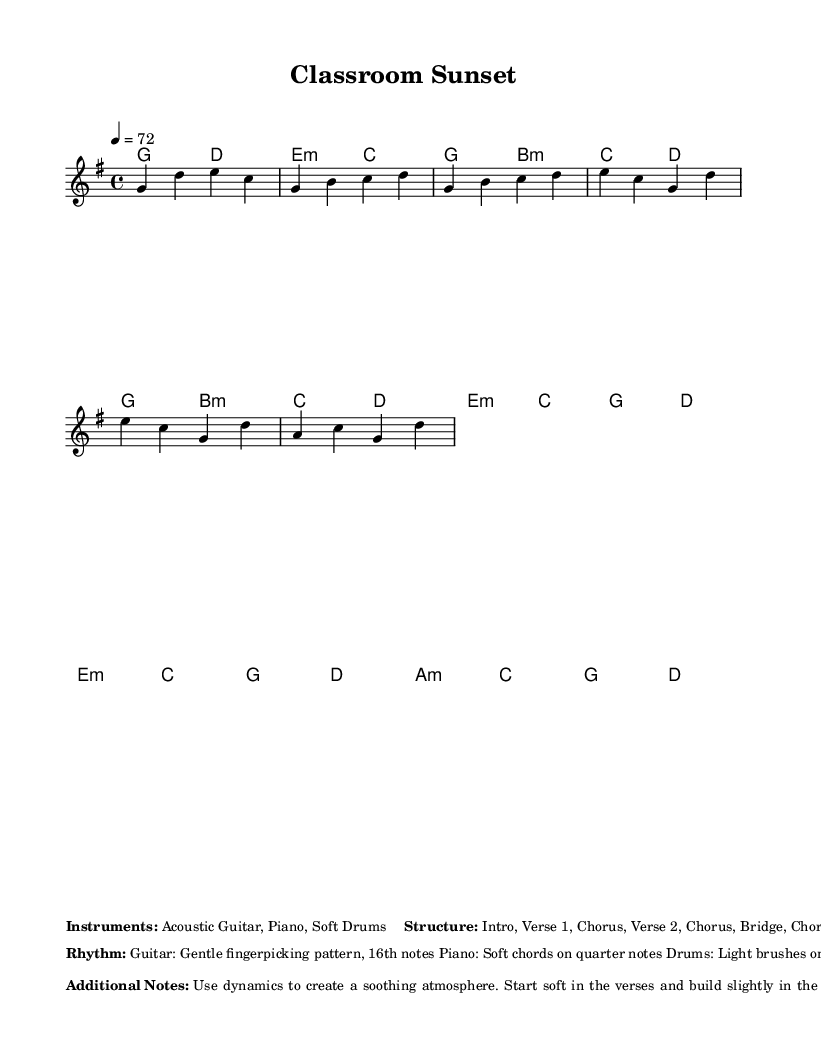What is the key signature of this music? The key signature is G major, which includes one sharp (F#). This can be determined by looking at the key signature symbol placed at the beginning of the staff in the sheet music.
Answer: G major What is the time signature of this piece? The time signature is 4/4, indicated at the beginning of the music. This means that there are four beats in a measure, and the quarter note receives one beat.
Answer: 4/4 What is the tempo marking for this piece? The tempo marking is 72 beats per minute, which is shown as "4 = 72" at the beginning of the score. This means that a quarter note equals 72 beats per minute.
Answer: 72 How many sections does the music contain? The music contains eight sections: Intro, Verse 1, Chorus, Verse 2, Chorus, Bridge, Chorus, and Outro. This can be inferred from the structure outlined in the markup.
Answer: Eight What instruments are specified for this piece? The specified instruments are Acoustic Guitar, Piano, and Soft Drums. This information is mentioned in the markup section of the sheet music.
Answer: Acoustic Guitar, Piano, Soft Drums What rhythmic pattern is suggested for the guitar? The rhythmic pattern suggested for the guitar is a Gentle fingerpicking pattern in 16th notes. This detail is included in the rhythm description in the markup.
Answer: Gentle fingerpicking pattern, 16th notes What dynamics are recommended for the verses? The recommended dynamics for the verses are to start soft. This suggestion is found in the additional notes of the markup, which emphasize creating a soothing atmosphere.
Answer: Start soft 